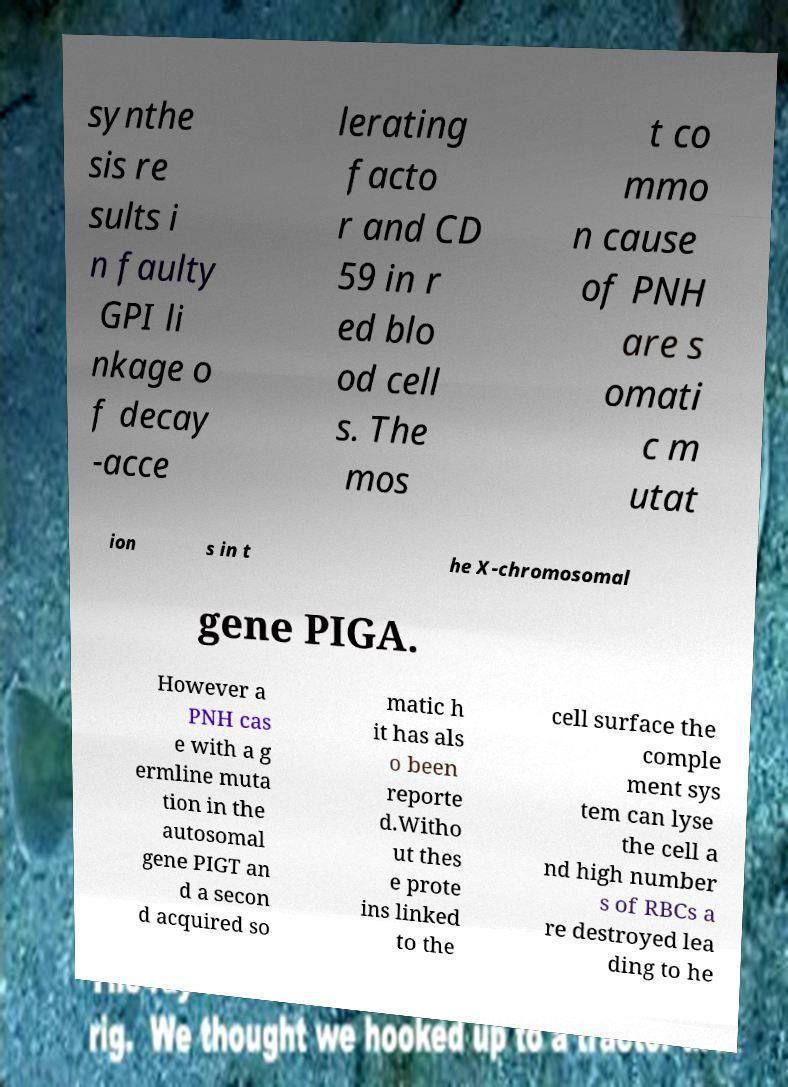What messages or text are displayed in this image? I need them in a readable, typed format. synthe sis re sults i n faulty GPI li nkage o f decay -acce lerating facto r and CD 59 in r ed blo od cell s. The mos t co mmo n cause of PNH are s omati c m utat ion s in t he X-chromosomal gene PIGA. However a PNH cas e with a g ermline muta tion in the autosomal gene PIGT an d a secon d acquired so matic h it has als o been reporte d.Witho ut thes e prote ins linked to the cell surface the comple ment sys tem can lyse the cell a nd high number s of RBCs a re destroyed lea ding to he 